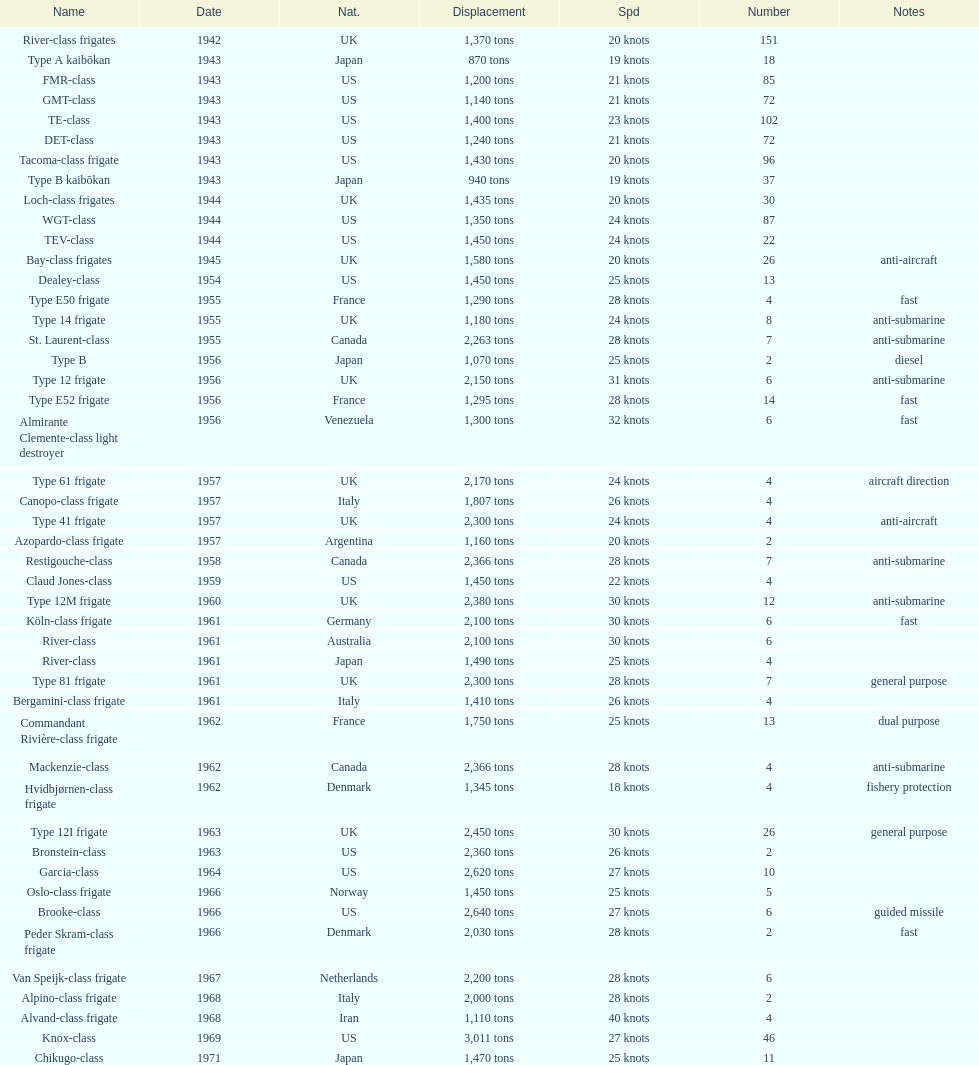Which name possesses the largest displacement? Knox-class. 